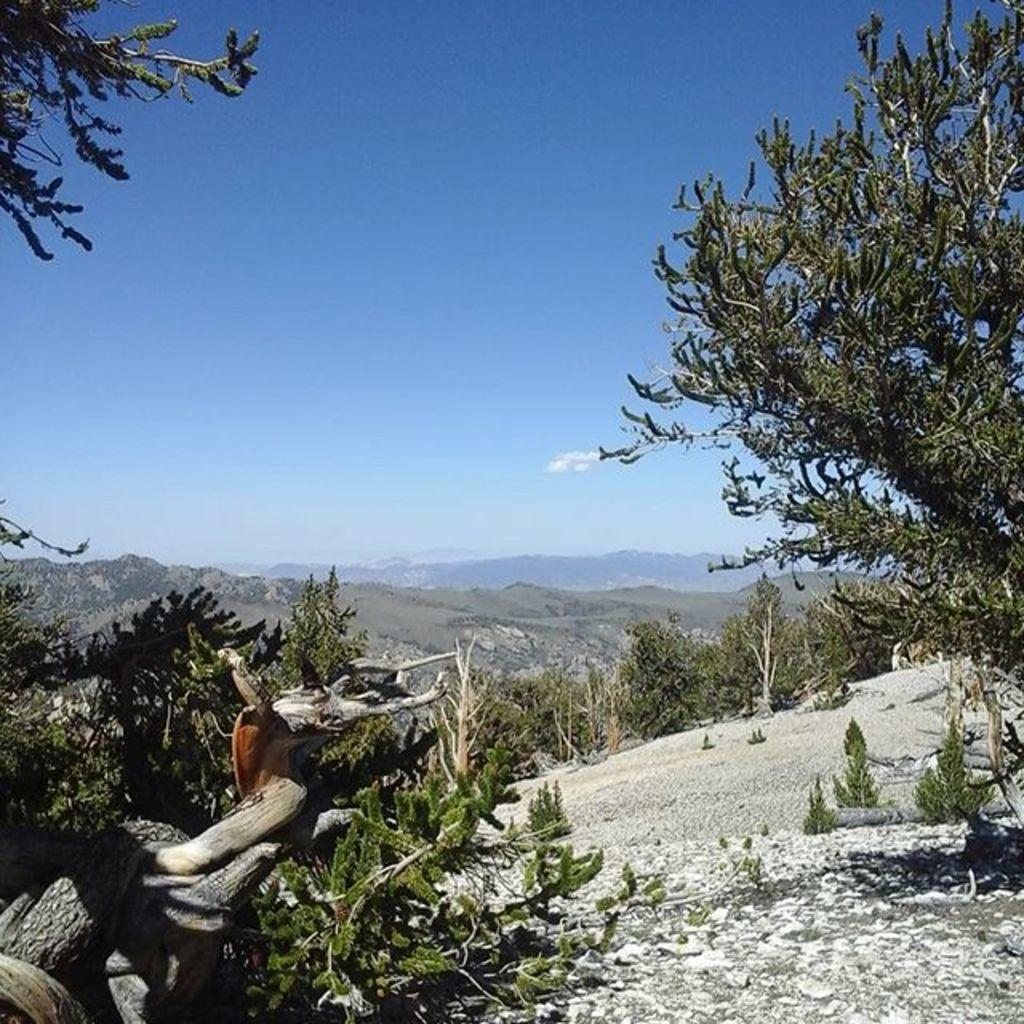Can you describe this image briefly? In this picture we can see a branch, plants and trees. Behind the trees, there are hills and the sky. 